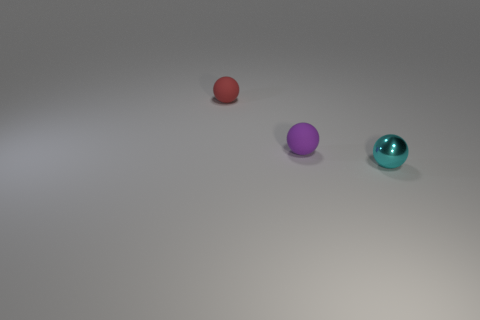What is the color of the sphere that is made of the same material as the red thing?
Offer a very short reply. Purple. Does the small red sphere have the same material as the tiny purple sphere that is to the right of the tiny red thing?
Offer a very short reply. Yes. How many objects are tiny cyan spheres or big purple metal blocks?
Your answer should be very brief. 1. Are there any other tiny red things that have the same shape as the metallic object?
Provide a succinct answer. Yes. What number of balls are in front of the tiny cyan metallic thing?
Your answer should be compact. 0. There is a purple sphere on the right side of the rubber object that is to the left of the purple object; what is it made of?
Your answer should be very brief. Rubber. There is a cyan sphere that is the same size as the purple ball; what material is it?
Provide a short and direct response. Metal. Are there any metallic balls that have the same size as the purple object?
Your answer should be compact. Yes. There is a small thing on the right side of the small purple rubber thing; what is its color?
Ensure brevity in your answer.  Cyan. There is a small shiny object in front of the purple thing; is there a small cyan shiny object that is to the right of it?
Give a very brief answer. No. 